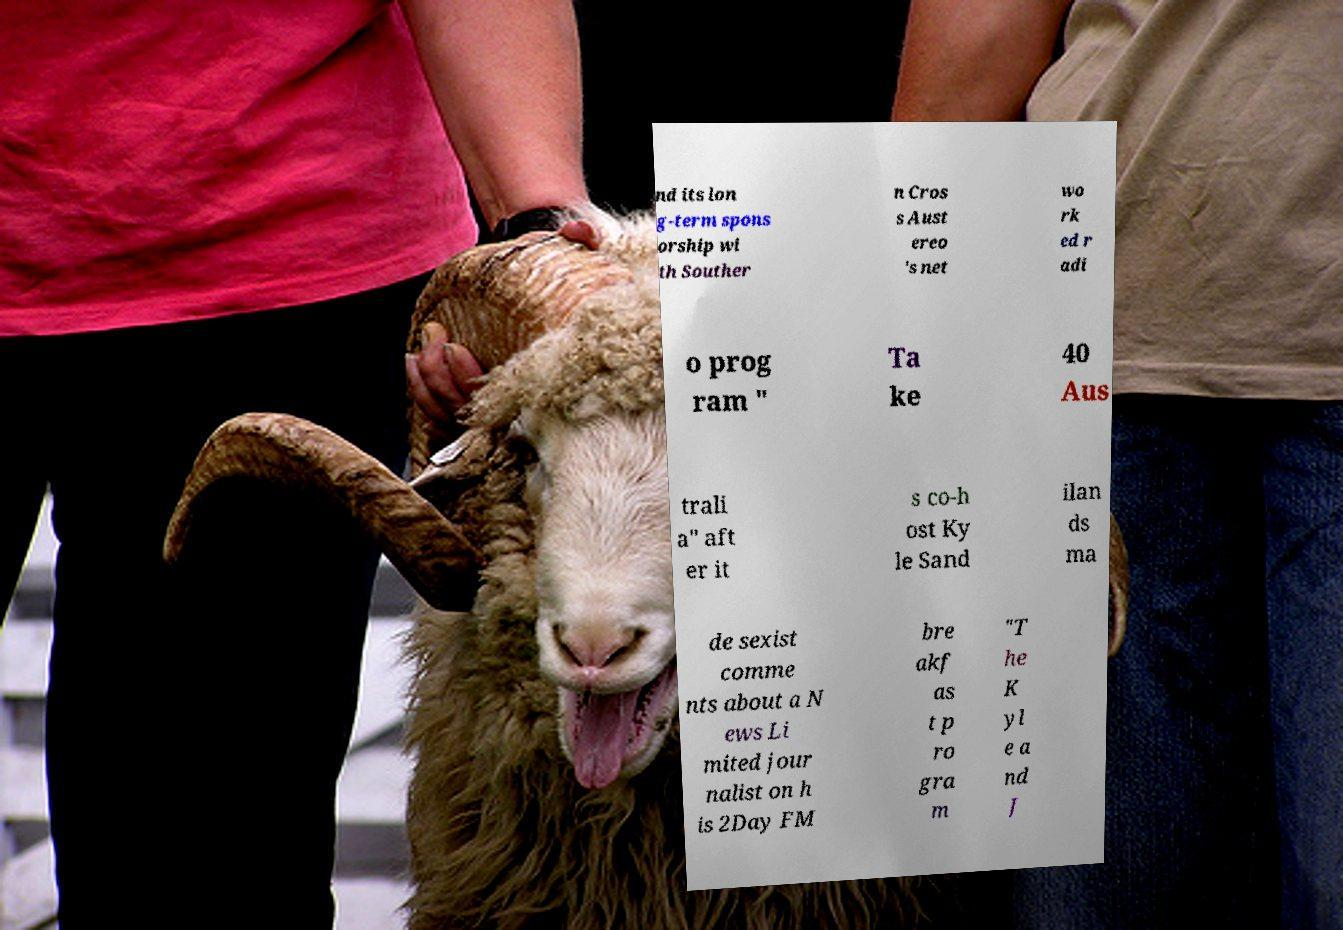Can you read and provide the text displayed in the image?This photo seems to have some interesting text. Can you extract and type it out for me? nd its lon g-term spons orship wi th Souther n Cros s Aust ereo 's net wo rk ed r adi o prog ram " Ta ke 40 Aus trali a" aft er it s co-h ost Ky le Sand ilan ds ma de sexist comme nts about a N ews Li mited jour nalist on h is 2Day FM bre akf as t p ro gra m "T he K yl e a nd J 